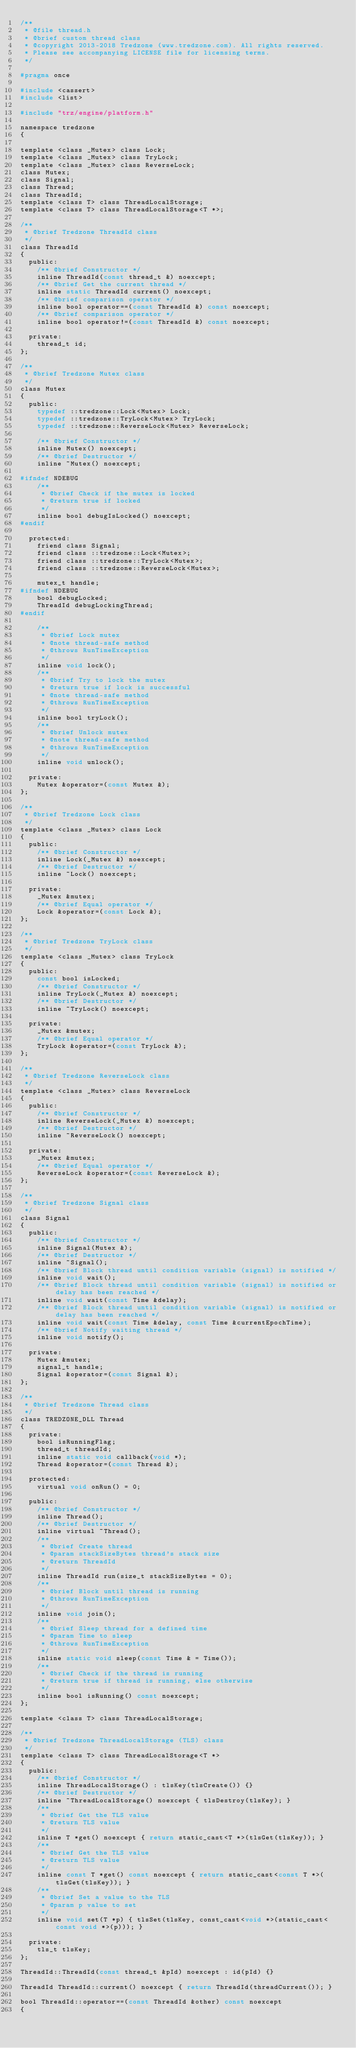Convert code to text. <code><loc_0><loc_0><loc_500><loc_500><_C_>/**
 * @file thread.h
 * @brief custom thread class
 * @copyright 2013-2018 Tredzone (www.tredzone.com). All rights reserved.
 * Please see accompanying LICENSE file for licensing terms.
 */

#pragma once

#include <cassert>
#include <list>

#include "trz/engine/platform.h"

namespace tredzone
{

template <class _Mutex> class Lock;
template <class _Mutex> class TryLock;
template <class _Mutex> class ReverseLock;
class Mutex;
class Signal;
class Thread;
class ThreadId;
template <class T> class ThreadLocalStorage;
template <class T> class ThreadLocalStorage<T *>;

/**
 * @brief Tredzone ThreadId class
 */
class ThreadId
{
  public:
    /** @brief Constructor */
    inline ThreadId(const thread_t &) noexcept;
    /** @brief Get the current thread */
    inline static ThreadId current() noexcept;
    /** @brief comparison operator */
    inline bool operator==(const ThreadId &) const noexcept;
    /** @brief comparison operator */
    inline bool operator!=(const ThreadId &) const noexcept;

  private:
    thread_t id;
};

/**
 * @brief Tredzone Mutex class
 */
class Mutex
{
  public:
    typedef ::tredzone::Lock<Mutex> Lock;
    typedef ::tredzone::TryLock<Mutex> TryLock;
    typedef ::tredzone::ReverseLock<Mutex> ReverseLock;

    /** @brief Constructor */
    inline Mutex() noexcept;
    /** @brief Destructor */
    inline ~Mutex() noexcept;

#ifndef NDEBUG
    /**
     * @brief Check if the mutex is locked
     * @return true if locked
     */
    inline bool debugIsLocked() noexcept;
#endif

  protected:
    friend class Signal;
    friend class ::tredzone::Lock<Mutex>;
    friend class ::tredzone::TryLock<Mutex>;
    friend class ::tredzone::ReverseLock<Mutex>;

    mutex_t handle;
#ifndef NDEBUG
    bool debugLocked;
    ThreadId debugLockingThread;
#endif

    /**
     * @brief Lock mutex
     * @note thread-safe method
     * @throws RunTimeException
     */
    inline void lock();
    /**
     * @brief Try to lock the mutex
     * @return true if lock is successful
     * @note thread-safe method
     * @throws RunTimeException
     */
    inline bool tryLock();
    /**
     * @brief Unlock mutex
     * @note thread-safe method
     * @throws RunTimeException
     */
    inline void unlock();

  private:
    Mutex &operator=(const Mutex &);
};

/**
 * @brief Tredzone Lock class
 */
template <class _Mutex> class Lock
{
  public:
    /** @brief Constructor */
    inline Lock(_Mutex &) noexcept;
    /** @brief Destructor */
    inline ~Lock() noexcept;

  private:
    _Mutex &mutex;
    /** @brief Equal operator */
    Lock &operator=(const Lock &);
};

/**
 * @brief Tredzone TryLock class
 */
template <class _Mutex> class TryLock
{
  public:
    const bool isLocked;
    /** @brief Constructor */
    inline TryLock(_Mutex &) noexcept;
    /** @brief Destructor */
    inline ~TryLock() noexcept;

  private:
    _Mutex &mutex;
    /** @brief Equal operator */
    TryLock &operator=(const TryLock &);
};

/**
 * @brief Tredzone ReverseLock class
 */
template <class _Mutex> class ReverseLock
{
  public:
    /** @brief Constructor */
    inline ReverseLock(_Mutex &) noexcept;
    /** @brief Destructor */
    inline ~ReverseLock() noexcept;

  private:
    _Mutex &mutex;
    /** @brief Equal operator */
    ReverseLock &operator=(const ReverseLock &);
};

/**
 * @brief Tredzone Signal class
 */
class Signal
{
  public:
    /** @brief Constructor */
    inline Signal(Mutex &);
    /** @brief Destructor */
    inline ~Signal();
    /** @brief Block thread until condition variable (signal) is notified */
    inline void wait();
    /** @brief Block thread until condition variable (signal) is notified or delay has been reached */
    inline void wait(const Time &delay);
    /** @brief Block thread until condition variable (signal) is notified or delay has been reached */
    inline void wait(const Time &delay, const Time &currentEpochTime);
    /** @brief Notify waiting thread */
    inline void notify();

  private:
    Mutex &mutex;
    signal_t handle;
    Signal &operator=(const Signal &);
};

/**
 * @brief Tredzone Thread class
 */
class TREDZONE_DLL Thread
{
  private:
    bool isRunningFlag;
    thread_t threadId;
    inline static void callback(void *);
    Thread &operator=(const Thread &);

  protected:
    virtual void onRun() = 0;

  public:
    /** @brief Constructor */
    inline Thread();
    /** @brief Destructor */
    inline virtual ~Thread();
    /**
     * @brief Create thread
     * @param stackSizeBytes thread's stack size
     * @return ThreadId
     */
    inline ThreadId run(size_t stackSizeBytes = 0);
    /**
     * @brief Block until thread is running
     * @throws RunTimeException
     */
    inline void join();
    /**
     * @brief Sleep thread for a defined time
     * @param Time to sleep
     * @throws RunTimeException
     */
    inline static void sleep(const Time & = Time());
    /**
     * @brief Check if the thread is running
     * @return true if thread is running, else otherwise
     */
    inline bool isRunning() const noexcept;
};

template <class T> class ThreadLocalStorage;

/**
 * @brief Tredzone ThreadLocalStorage (TLS) class
 */
template <class T> class ThreadLocalStorage<T *>
{
  public:
    /** @brief Constructor */
    inline ThreadLocalStorage() : tlsKey(tlsCreate()) {}
    /** @brief Destructor */
    inline ~ThreadLocalStorage() noexcept { tlsDestroy(tlsKey); }
    /**
     * @brief Get the TLS value
     * @return TLS value
     */
    inline T *get() noexcept { return static_cast<T *>(tlsGet(tlsKey)); }
    /**
     * @brief Get the TLS value
     * @return TLS value
     */
    inline const T *get() const noexcept { return static_cast<const T *>(tlsGet(tlsKey)); }
    /**
     * @brief Set a value to the TLS
     * @param p value to set
     */
    inline void set(T *p) { tlsSet(tlsKey, const_cast<void *>(static_cast<const void *>(p))); }

  private:
    tls_t tlsKey;
};

ThreadId::ThreadId(const thread_t &pId) noexcept : id(pId) {}

ThreadId ThreadId::current() noexcept { return ThreadId(threadCurrent()); }

bool ThreadId::operator==(const ThreadId &other) const noexcept
{</code> 